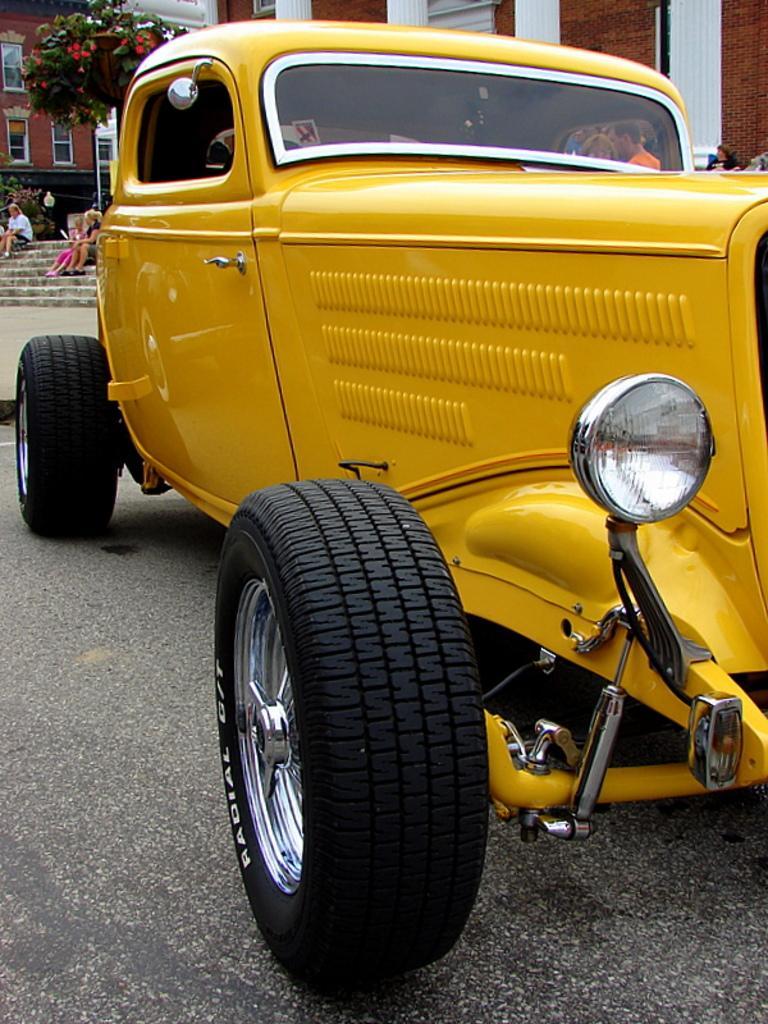Could you give a brief overview of what you see in this image? In the foreground we can see car and road. On the left there are people, staircase, tree, plant and building. In the background we can see building. On the right we can see a person. 